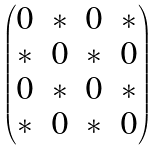<formula> <loc_0><loc_0><loc_500><loc_500>\begin{pmatrix} 0 & * & 0 & * \\ * & 0 & * & 0 \\ 0 & * & 0 & * \\ * & 0 & * & 0 \end{pmatrix}</formula> 